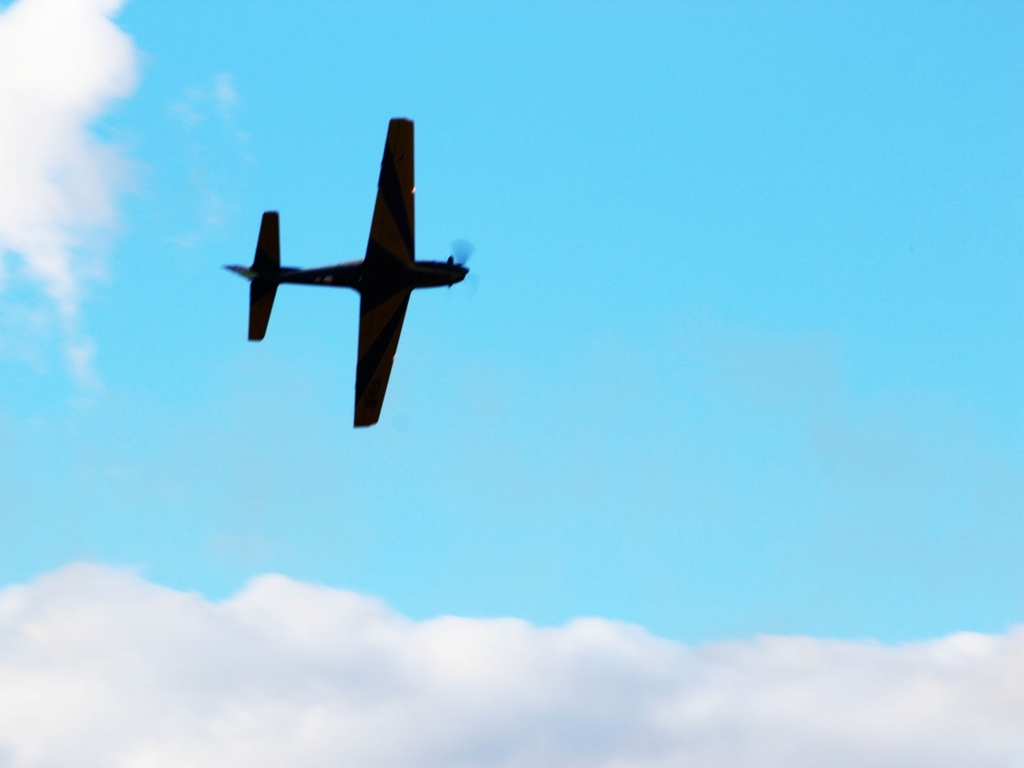What type of aircraft is shown in the picture, and can you tell if it's in motion? The image shows an aircraft that appears to be a light propeller-driven airplane, possibly used for recreational flying or training. The motion blur on the propeller and its position high in the sky indicate that it is indeed in motion, likely flying at a consistent speed. How can you determine the speed of the aircraft from the image, and what could be the possible destination? Precise speed measurement isn't possible from a single image, but the lack of significant motion blur on the airplane's body suggests it's not moving at a high speed. The destination of the aircraft is not discernible from the image alone; it would require knowledge about the aircraft's flight plan or current heading. 